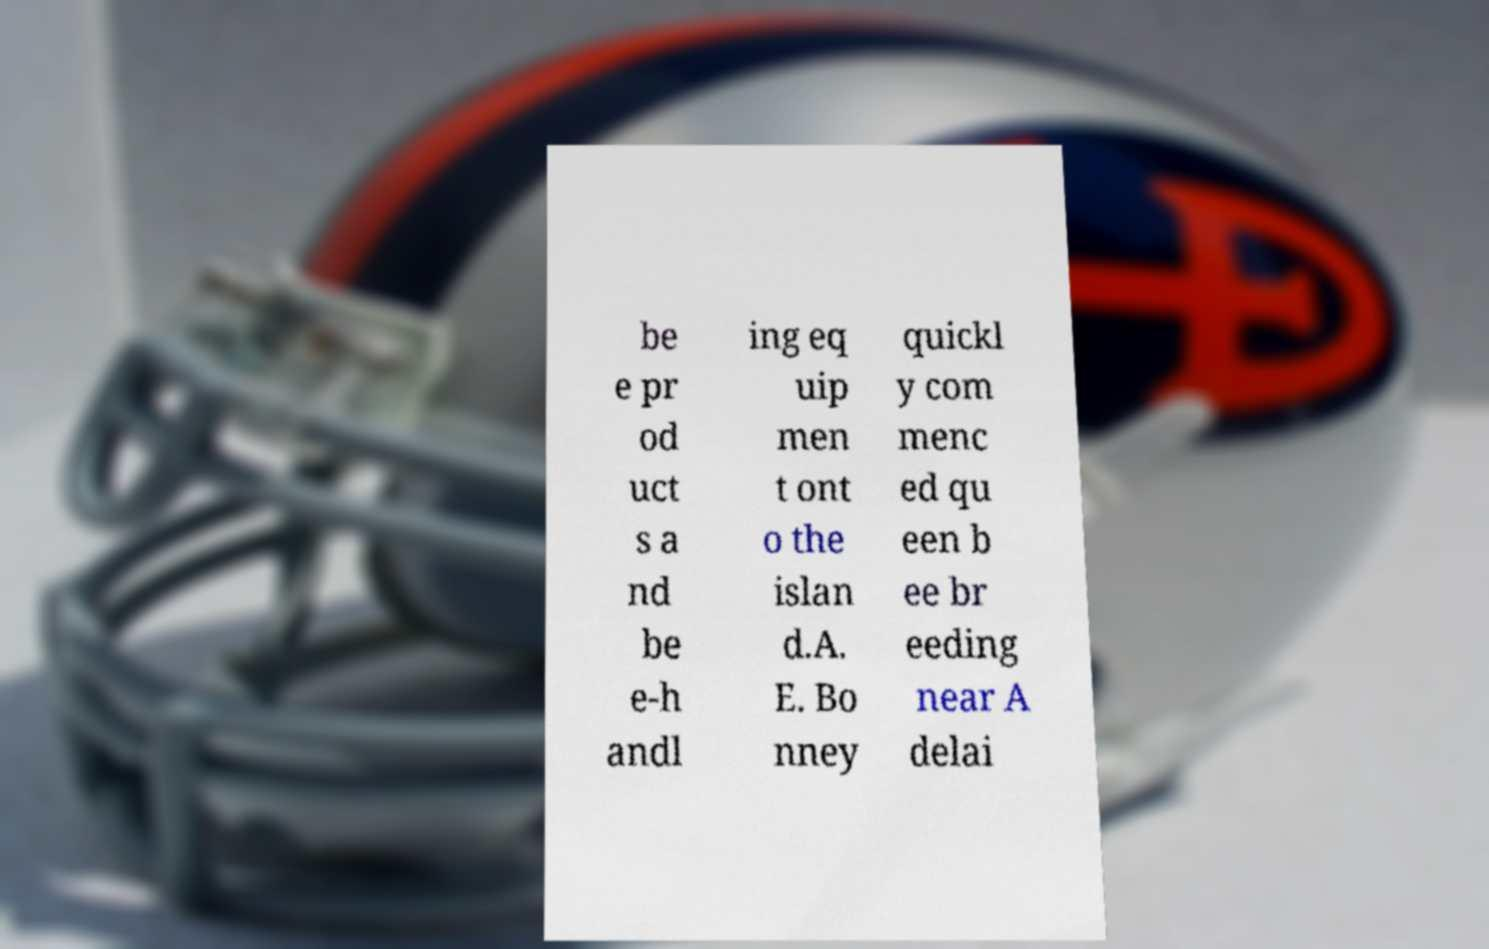What messages or text are displayed in this image? I need them in a readable, typed format. be e pr od uct s a nd be e-h andl ing eq uip men t ont o the islan d.A. E. Bo nney quickl y com menc ed qu een b ee br eeding near A delai 